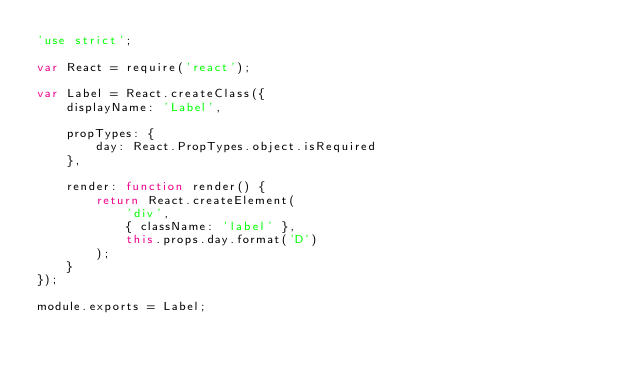Convert code to text. <code><loc_0><loc_0><loc_500><loc_500><_JavaScript_>'use strict';

var React = require('react');

var Label = React.createClass({
    displayName: 'Label',

    propTypes: {
        day: React.PropTypes.object.isRequired
    },

    render: function render() {
        return React.createElement(
            'div',
            { className: 'label' },
            this.props.day.format('D')
        );
    }
});

module.exports = Label;</code> 